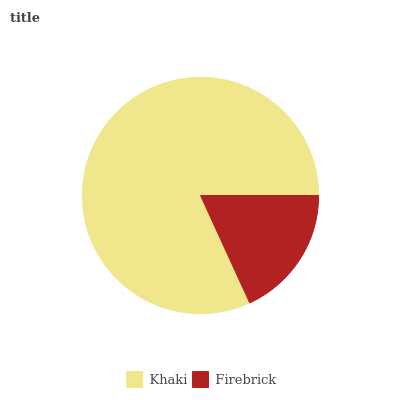Is Firebrick the minimum?
Answer yes or no. Yes. Is Khaki the maximum?
Answer yes or no. Yes. Is Firebrick the maximum?
Answer yes or no. No. Is Khaki greater than Firebrick?
Answer yes or no. Yes. Is Firebrick less than Khaki?
Answer yes or no. Yes. Is Firebrick greater than Khaki?
Answer yes or no. No. Is Khaki less than Firebrick?
Answer yes or no. No. Is Khaki the high median?
Answer yes or no. Yes. Is Firebrick the low median?
Answer yes or no. Yes. Is Firebrick the high median?
Answer yes or no. No. Is Khaki the low median?
Answer yes or no. No. 